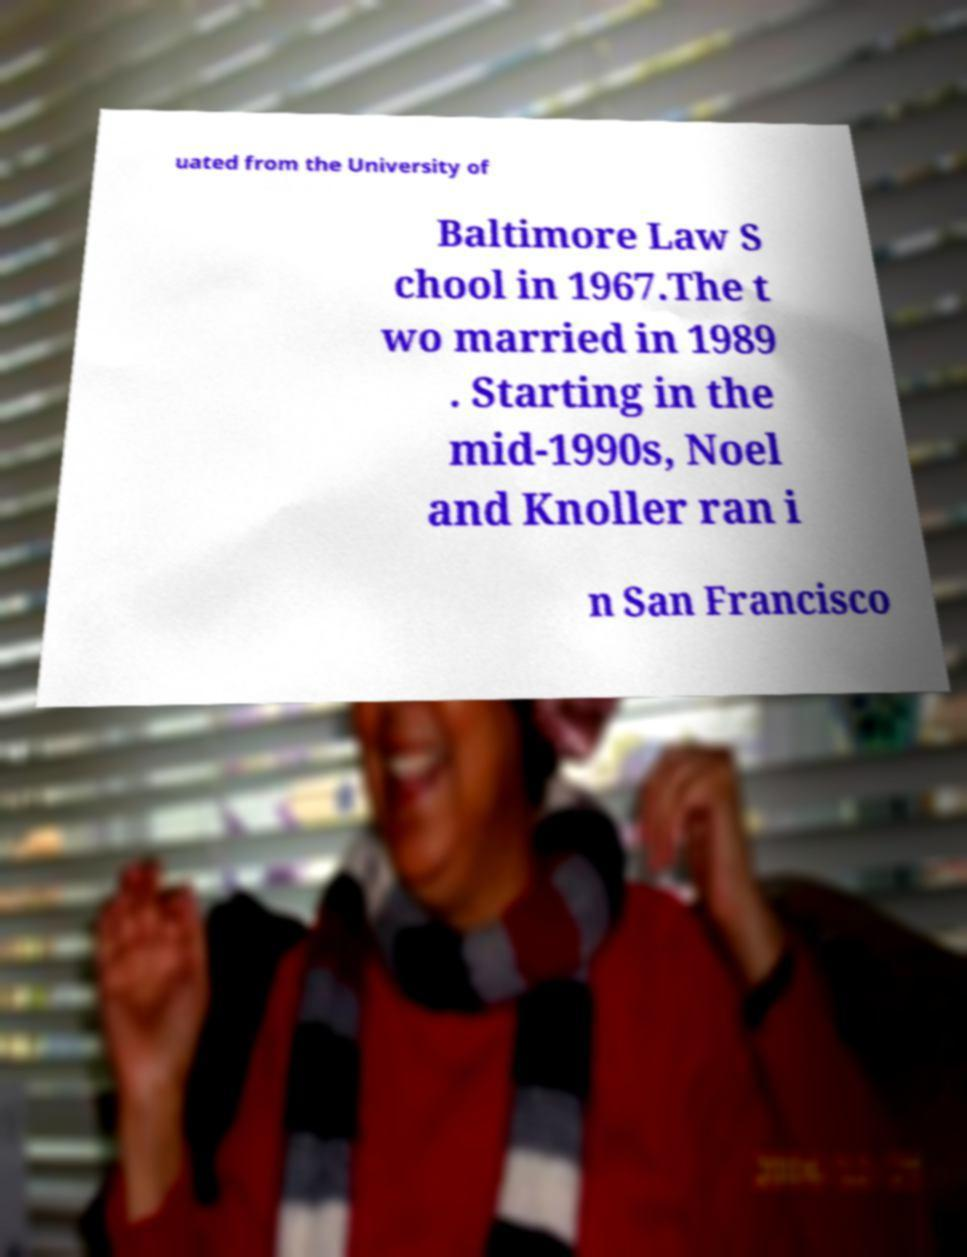I need the written content from this picture converted into text. Can you do that? uated from the University of Baltimore Law S chool in 1967.The t wo married in 1989 . Starting in the mid-1990s, Noel and Knoller ran i n San Francisco 